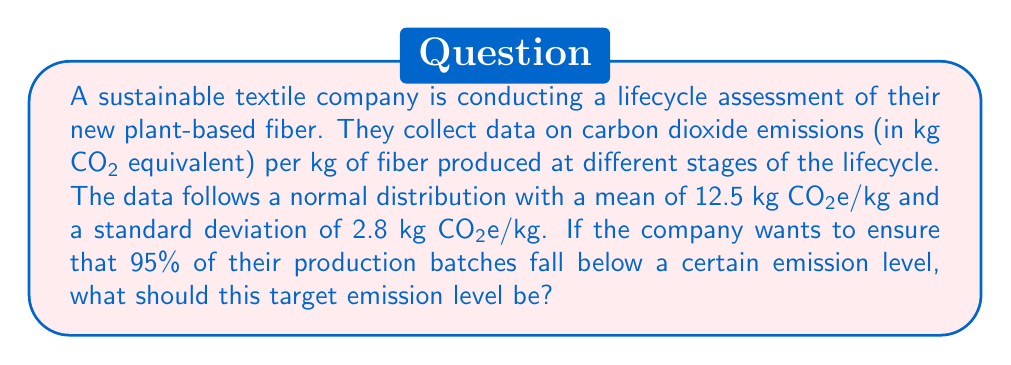Teach me how to tackle this problem. To solve this problem, we need to use the properties of the normal distribution and the concept of z-scores.

1. We are given:
   - Mean (μ) = 12.5 kg CO₂e/kg
   - Standard deviation (σ) = 2.8 kg CO₂e/kg
   - Desired percentile = 95%

2. In a normal distribution, the 95th percentile corresponds to 1.645 standard deviations above the mean. This value comes from the z-table for standard normal distribution.

3. We can use the z-score formula to find the target emission level (x):

   $$ z = \frac{x - \mu}{\sigma} $$

   Where z = 1.645 (for 95th percentile)

4. Rearranging the formula to solve for x:

   $$ x = \mu + z\sigma $$

5. Substituting the values:

   $$ x = 12.5 + 1.645 * 2.8 $$

6. Calculating:

   $$ x = 12.5 + 4.606 = 17.106 $$

Therefore, the target emission level should be set at approximately 17.11 kg CO₂e/kg to ensure that 95% of production batches fall below this level.
Answer: 17.11 kg CO₂e/kg 